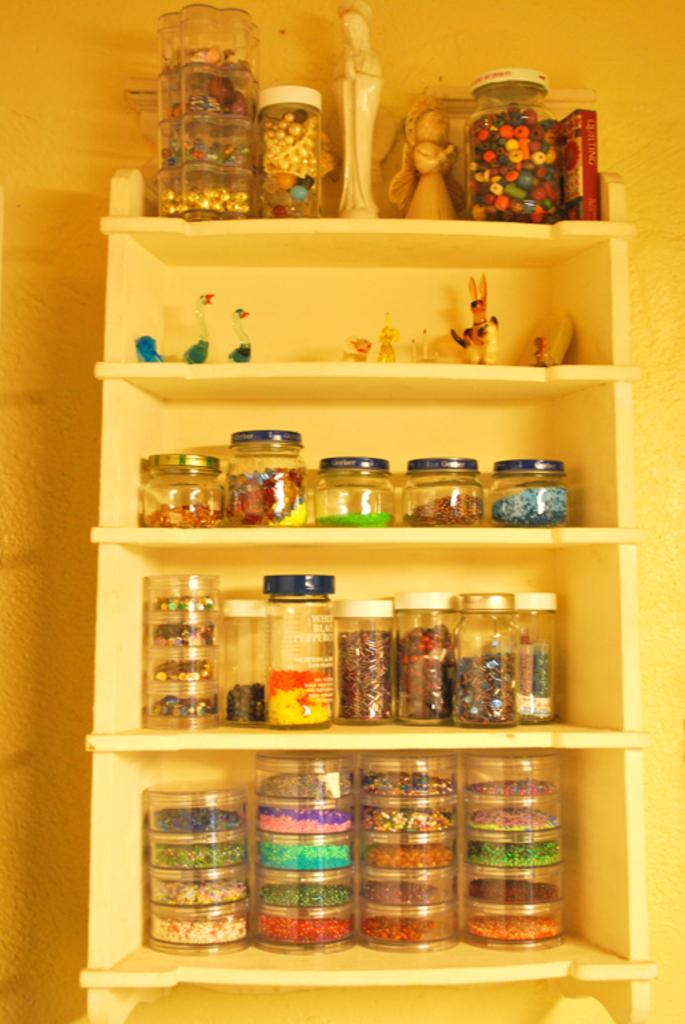What types of objects can be seen in the image? There are jars, statues, and toys in the image. Are there any objects arranged in a specific manner in the image? Yes, there are objects in racks in the image. What type of scissors can be seen in the image? There are no scissors present in the image. Are the statues in the image engaged in a fight? The image does not depict any fighting or conflict between the statues. 